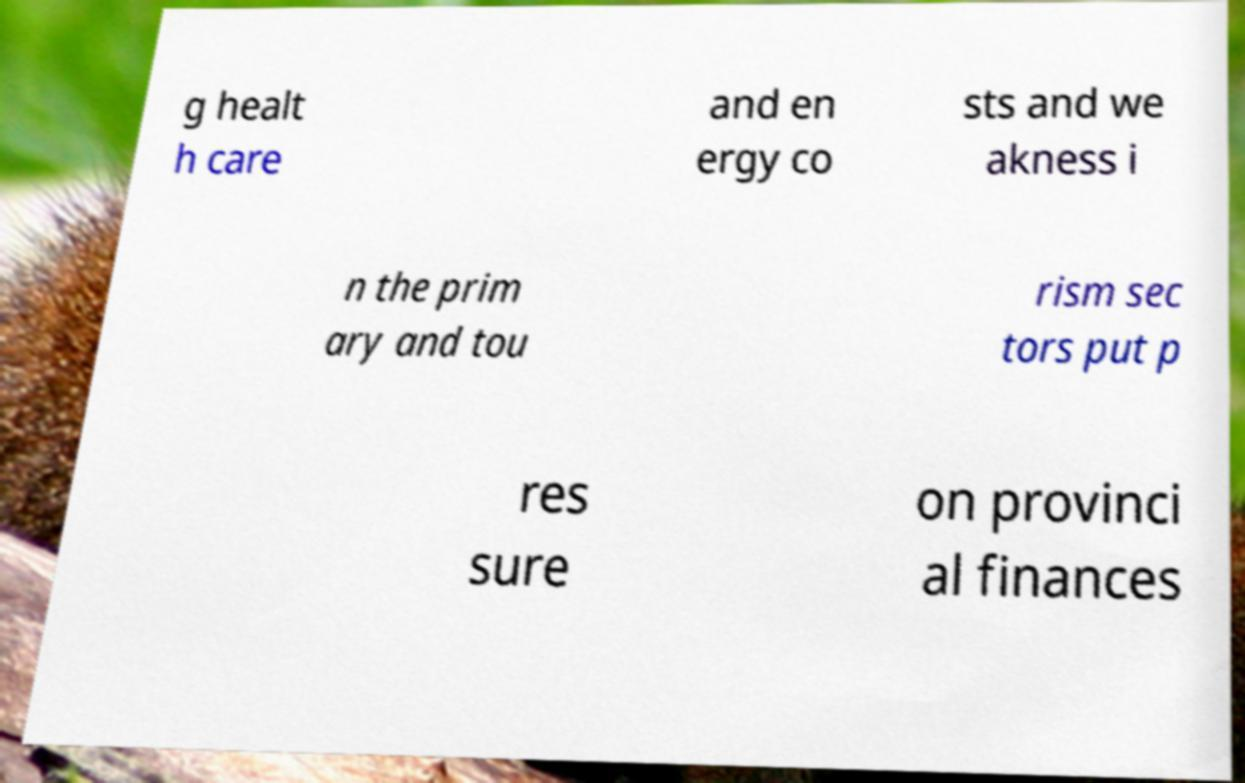There's text embedded in this image that I need extracted. Can you transcribe it verbatim? g healt h care and en ergy co sts and we akness i n the prim ary and tou rism sec tors put p res sure on provinci al finances 